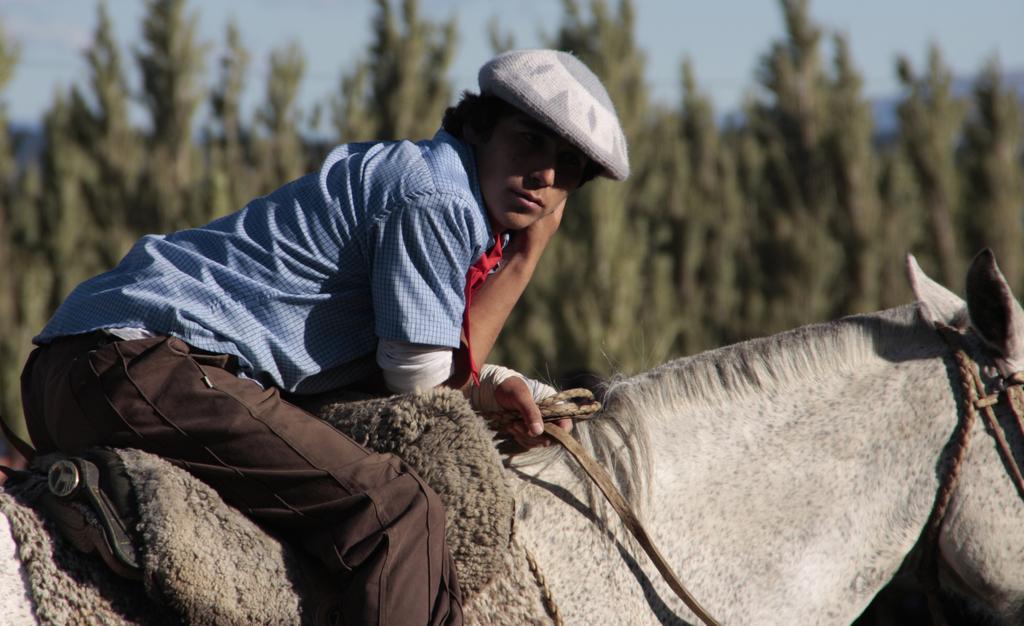Please provide a concise description of this image. In this image I can see a man is sitting on a horse, I can also see he is wearing a cap. In the background I can see number of trees. 